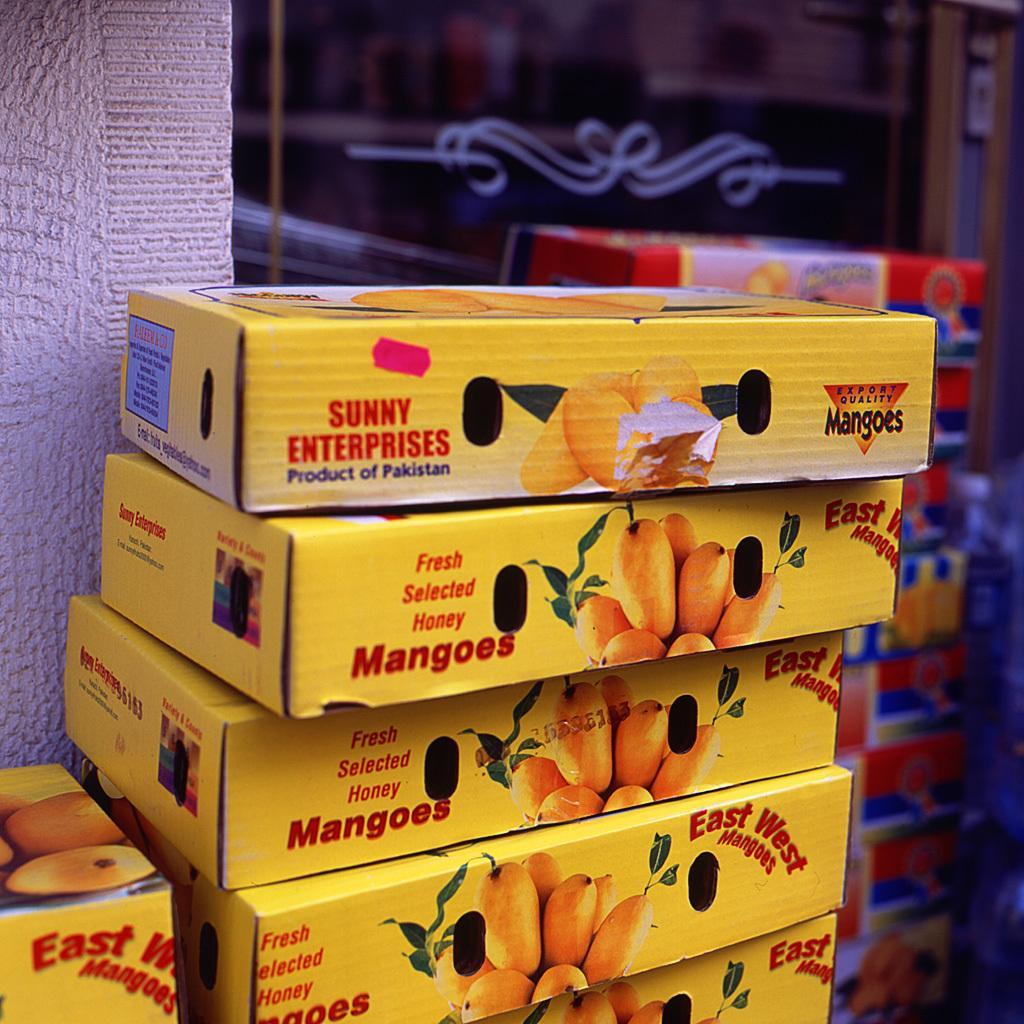In one or two sentences, can you explain what this image depicts? In this image we can see printed cardboard cartons arranged in a row. 